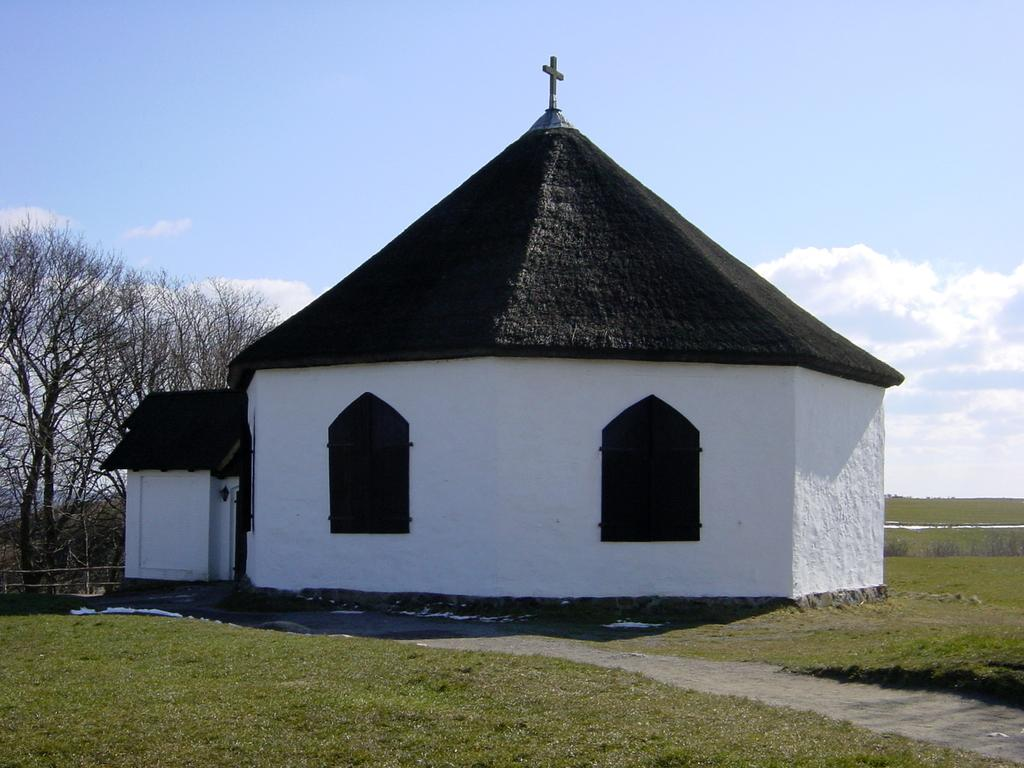What is the main structure in the center of the image? There is a building with two windows in the center of the image. What can be seen on the left side of the image? There is a group of trees on the left side of the image. What is visible in the background of the image? The sky is visible in the background of the image. How would you describe the sky in the image? The sky appears to be cloudy. Where is the sack located in the image? There is no sack present in the image. What type of machine can be seen operating in the background of the image? There is no machine present in the image. 